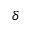Convert formula to latex. <formula><loc_0><loc_0><loc_500><loc_500>\delta</formula> 